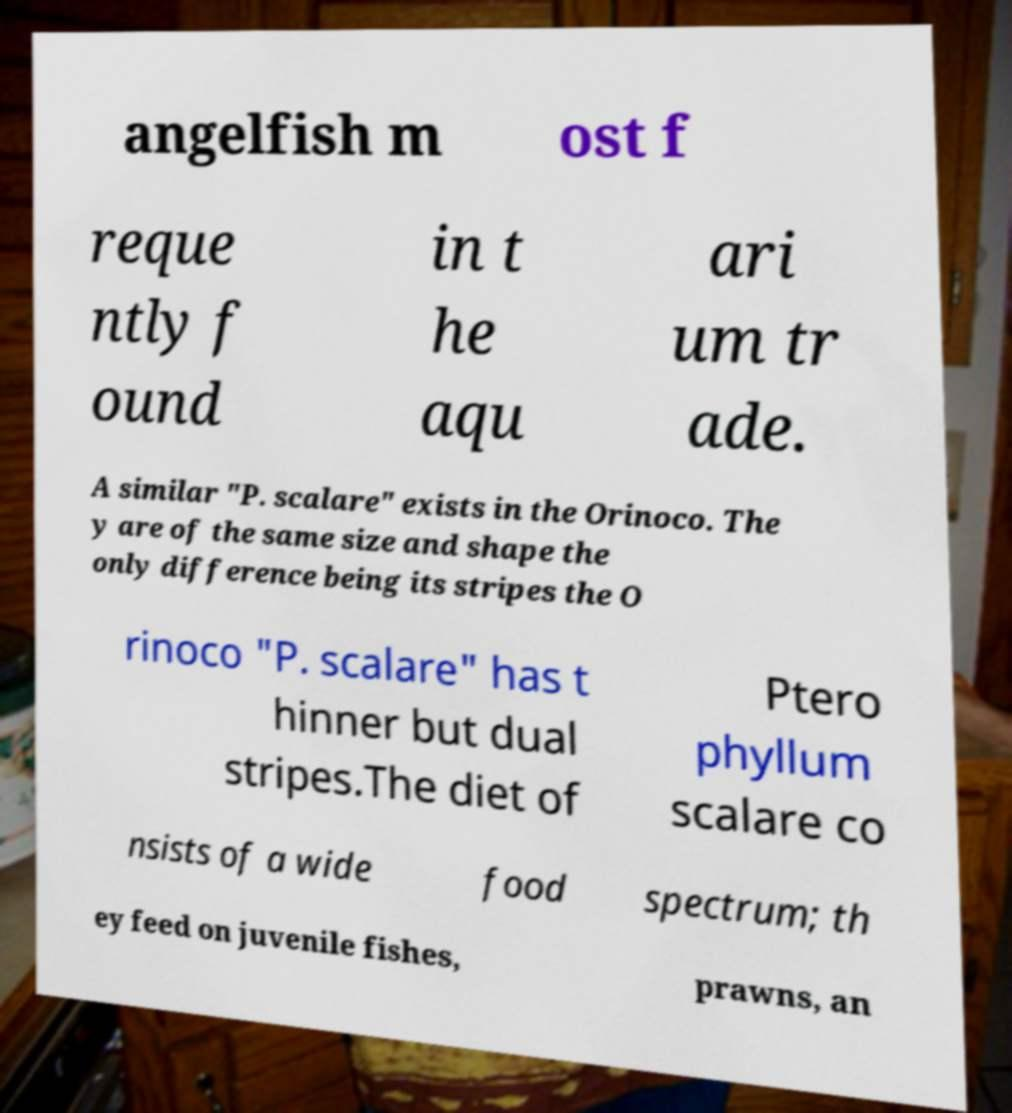What messages or text are displayed in this image? I need them in a readable, typed format. angelfish m ost f reque ntly f ound in t he aqu ari um tr ade. A similar "P. scalare" exists in the Orinoco. The y are of the same size and shape the only difference being its stripes the O rinoco "P. scalare" has t hinner but dual stripes.The diet of Ptero phyllum scalare co nsists of a wide food spectrum; th ey feed on juvenile fishes, prawns, an 